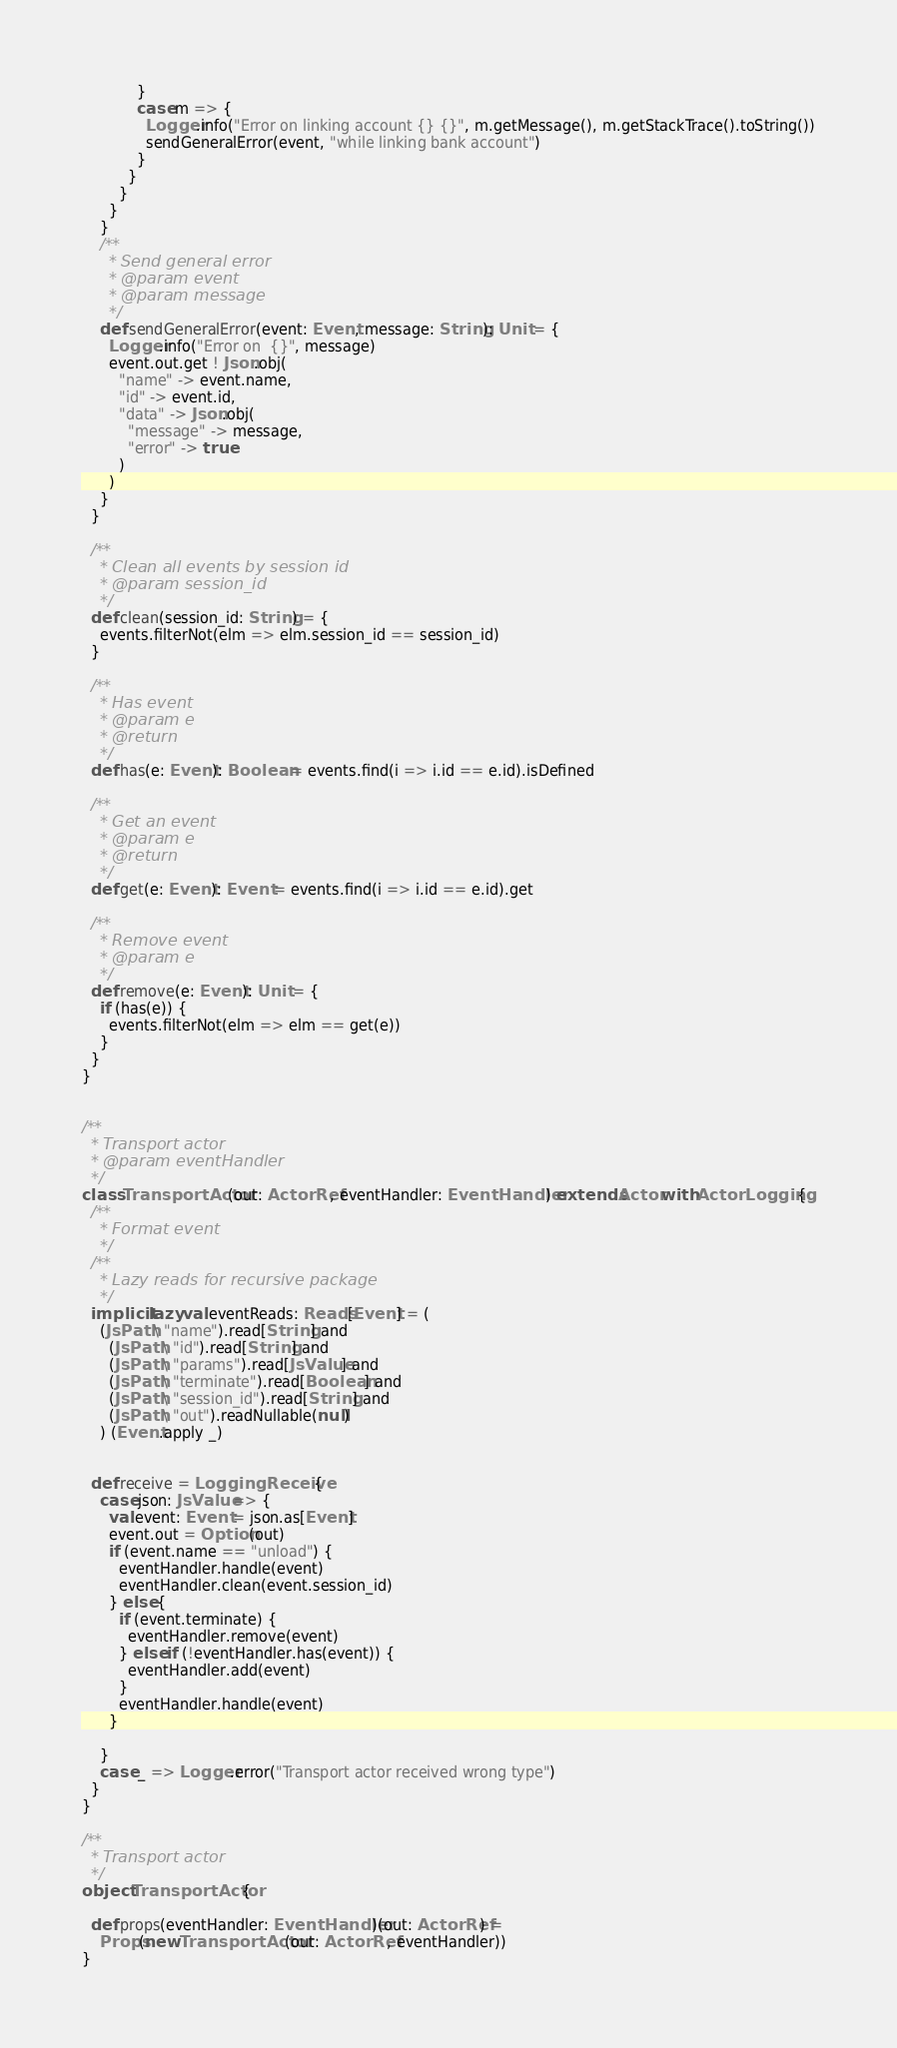<code> <loc_0><loc_0><loc_500><loc_500><_Scala_>            }
            case m => {
              Logger.info("Error on linking account {} {}", m.getMessage(), m.getStackTrace().toString())
              sendGeneralError(event, "while linking bank account")
            }
          }
        }
      }
    }
    /**
      * Send general error
      * @param event
      * @param message
      */
    def sendGeneralError(event: Event, message: String): Unit = {
      Logger.info("Error on  {}", message)
      event.out.get ! Json.obj(
        "name" -> event.name,
        "id" -> event.id,
        "data" -> Json.obj(
          "message" -> message,
          "error" -> true
        )
      )
    }
  }

  /**
    * Clean all events by session id
    * @param session_id
    */
  def clean(session_id: String) = {
    events.filterNot(elm => elm.session_id == session_id)
  }

  /**
    * Has event
    * @param e
    * @return
    */
  def has(e: Event): Boolean = events.find(i => i.id == e.id).isDefined

  /**
    * Get an event
    * @param e
    * @return
    */
  def get(e: Event): Event = events.find(i => i.id == e.id).get

  /**
    * Remove event
    * @param e
    */
  def remove(e: Event): Unit = {
    if (has(e)) {
      events.filterNot(elm => elm == get(e))
    }
  }
}


/**
  * Transport actor
  * @param eventHandler
  */
class TransportActor(out: ActorRef, eventHandler: EventHandler) extends Actor with ActorLogging {
  /**
    * Format event
    */
  /**
    * Lazy reads for recursive package
    */
  implicit lazy val eventReads: Reads[Event] = (
    (JsPath \ "name").read[String] and
      (JsPath \ "id").read[String] and
      (JsPath \ "params").read[JsValue] and
      (JsPath \ "terminate").read[Boolean] and
      (JsPath \ "session_id").read[String] and
      (JsPath \ "out").readNullable(null)
    ) (Event.apply _)


  def receive = LoggingReceive {
    case json: JsValue => {
      val event: Event = json.as[Event]
      event.out = Option(out)
      if (event.name == "unload") {
        eventHandler.handle(event)
        eventHandler.clean(event.session_id)
      } else {
        if (event.terminate) {
          eventHandler.remove(event)
        } else if (!eventHandler.has(event)) {
          eventHandler.add(event)
        }
        eventHandler.handle(event)
      }

    }
    case _ => Logger.error("Transport actor received wrong type")
  }
}

/**
  * Transport actor
  */
object TransportActor {

  def props(eventHandler: EventHandler)(out: ActorRef) =
    Props(new TransportActor(out: ActorRef, eventHandler))
}</code> 